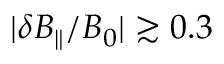Convert formula to latex. <formula><loc_0><loc_0><loc_500><loc_500>| \delta B _ { \| } / B _ { 0 } | \gtrsim 0 . 3</formula> 